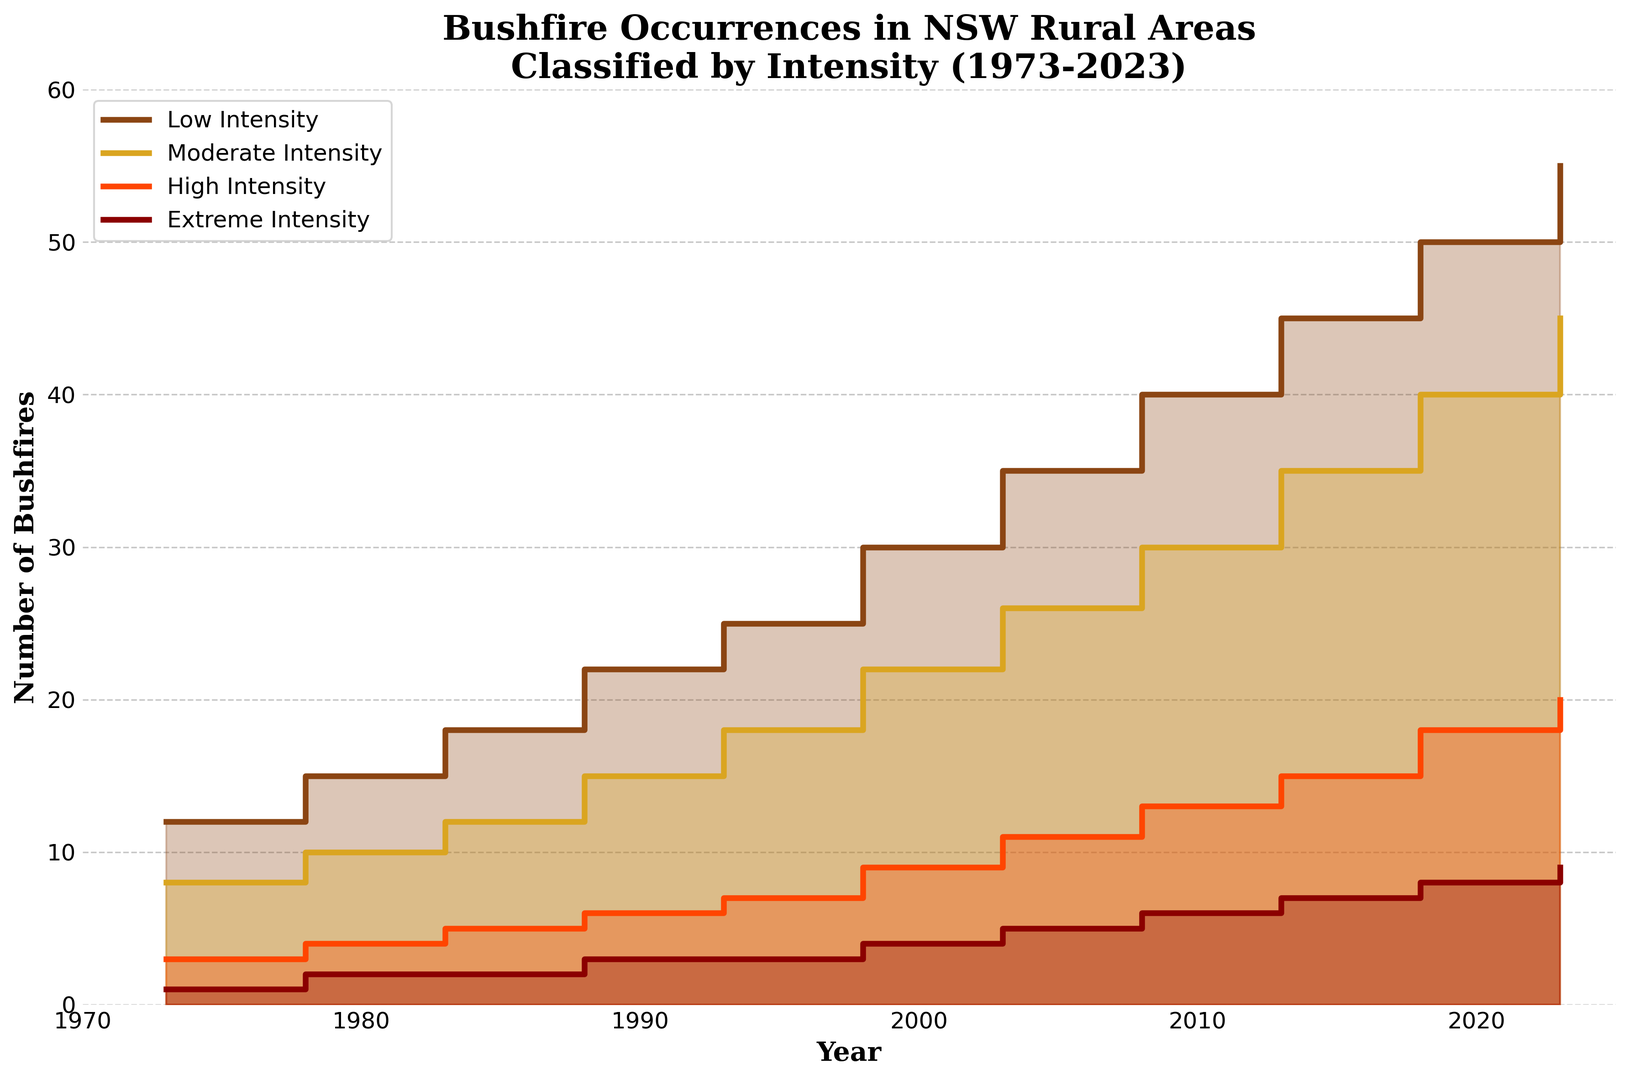What year saw the first instance of extreme intensity bushfires reaching nine occurrences? The plot shows a step increase in the number of extreme intensity bushfires over the years. The first occurrence of nine extreme intensity bushfires is seen at the data point for the year 2023.
Answer: 2023 How much did the number of moderate intensity bushfires increase from 1973 to 2023? To determine the increase, subtract the number of moderate intensity bushfires in 1973 from the number in 2023. In 1973, there were 8 moderate intensity bushfires, and in 2023, there were 45. Therefore, the increase is 45 - 8.
Answer: 37 In which year did the number of low intensity bushfires reach 30? By looking at the staircase pattern of the plot, we see that the number of low intensity bushfires reaches 30 in the year 1998.
Answer: 1998 Which intensity level saw the highest number of bushfires in 2003? In the year 2003, the plot shows that low intensity bushfires have the highest count compared to the other intensity levels. The exact number is 35.
Answer: Low Intensity By how many did high intensity bushfires surpass moderate intensity bushfires in the year 1983? From the figure, we see that in 1983, there are 12 moderate intensity bushfires and 5 high intensity bushfires. Subtracting, 12 - 5, gives the difference.
Answer: 7 During which decade did moderate intensity bushfires increase by the largest margin? To determine the decade with the largest increase, compare decade intervals: 8 (1973) to 15 (1983); 15 (1983) to 22 (1993); 22 (1993) to 30 (2003); and 30 (2003) to 40 (2013). The largest increase is seen from 2003 to 2013.
Answer: 2003-2013 How many more low intensity bushfires were there than extreme intensity bushfires in 2018? In the year 2018, the number of low intensity bushfires is 50, whereas extreme intensity bushfires are 8. The difference is calculated as 50 - 8.
Answer: 42 Which intensity of bushfires had the smallest increase in occurrences from 1993 to 2023? By checking the frequency of bushfires in 1993 and 2023 for each intensity, we get: Low (25 to 55), Moderate (18 to 45), High (7 to 20), Extreme (3 to 9). The smallest increase comes from extreme intensity bushfires with an increase of 6 (9 - 3).
Answer: Extreme Intensity What is the median number of moderate intensity bushfires over the years? Listing the moderate intensity counts: 8, 10, 12, 15, 18, 22, 26, 30, 35, 40, 45. With an odd count of 11 observations, the median is the middle value, which is 22.
Answer: 22 